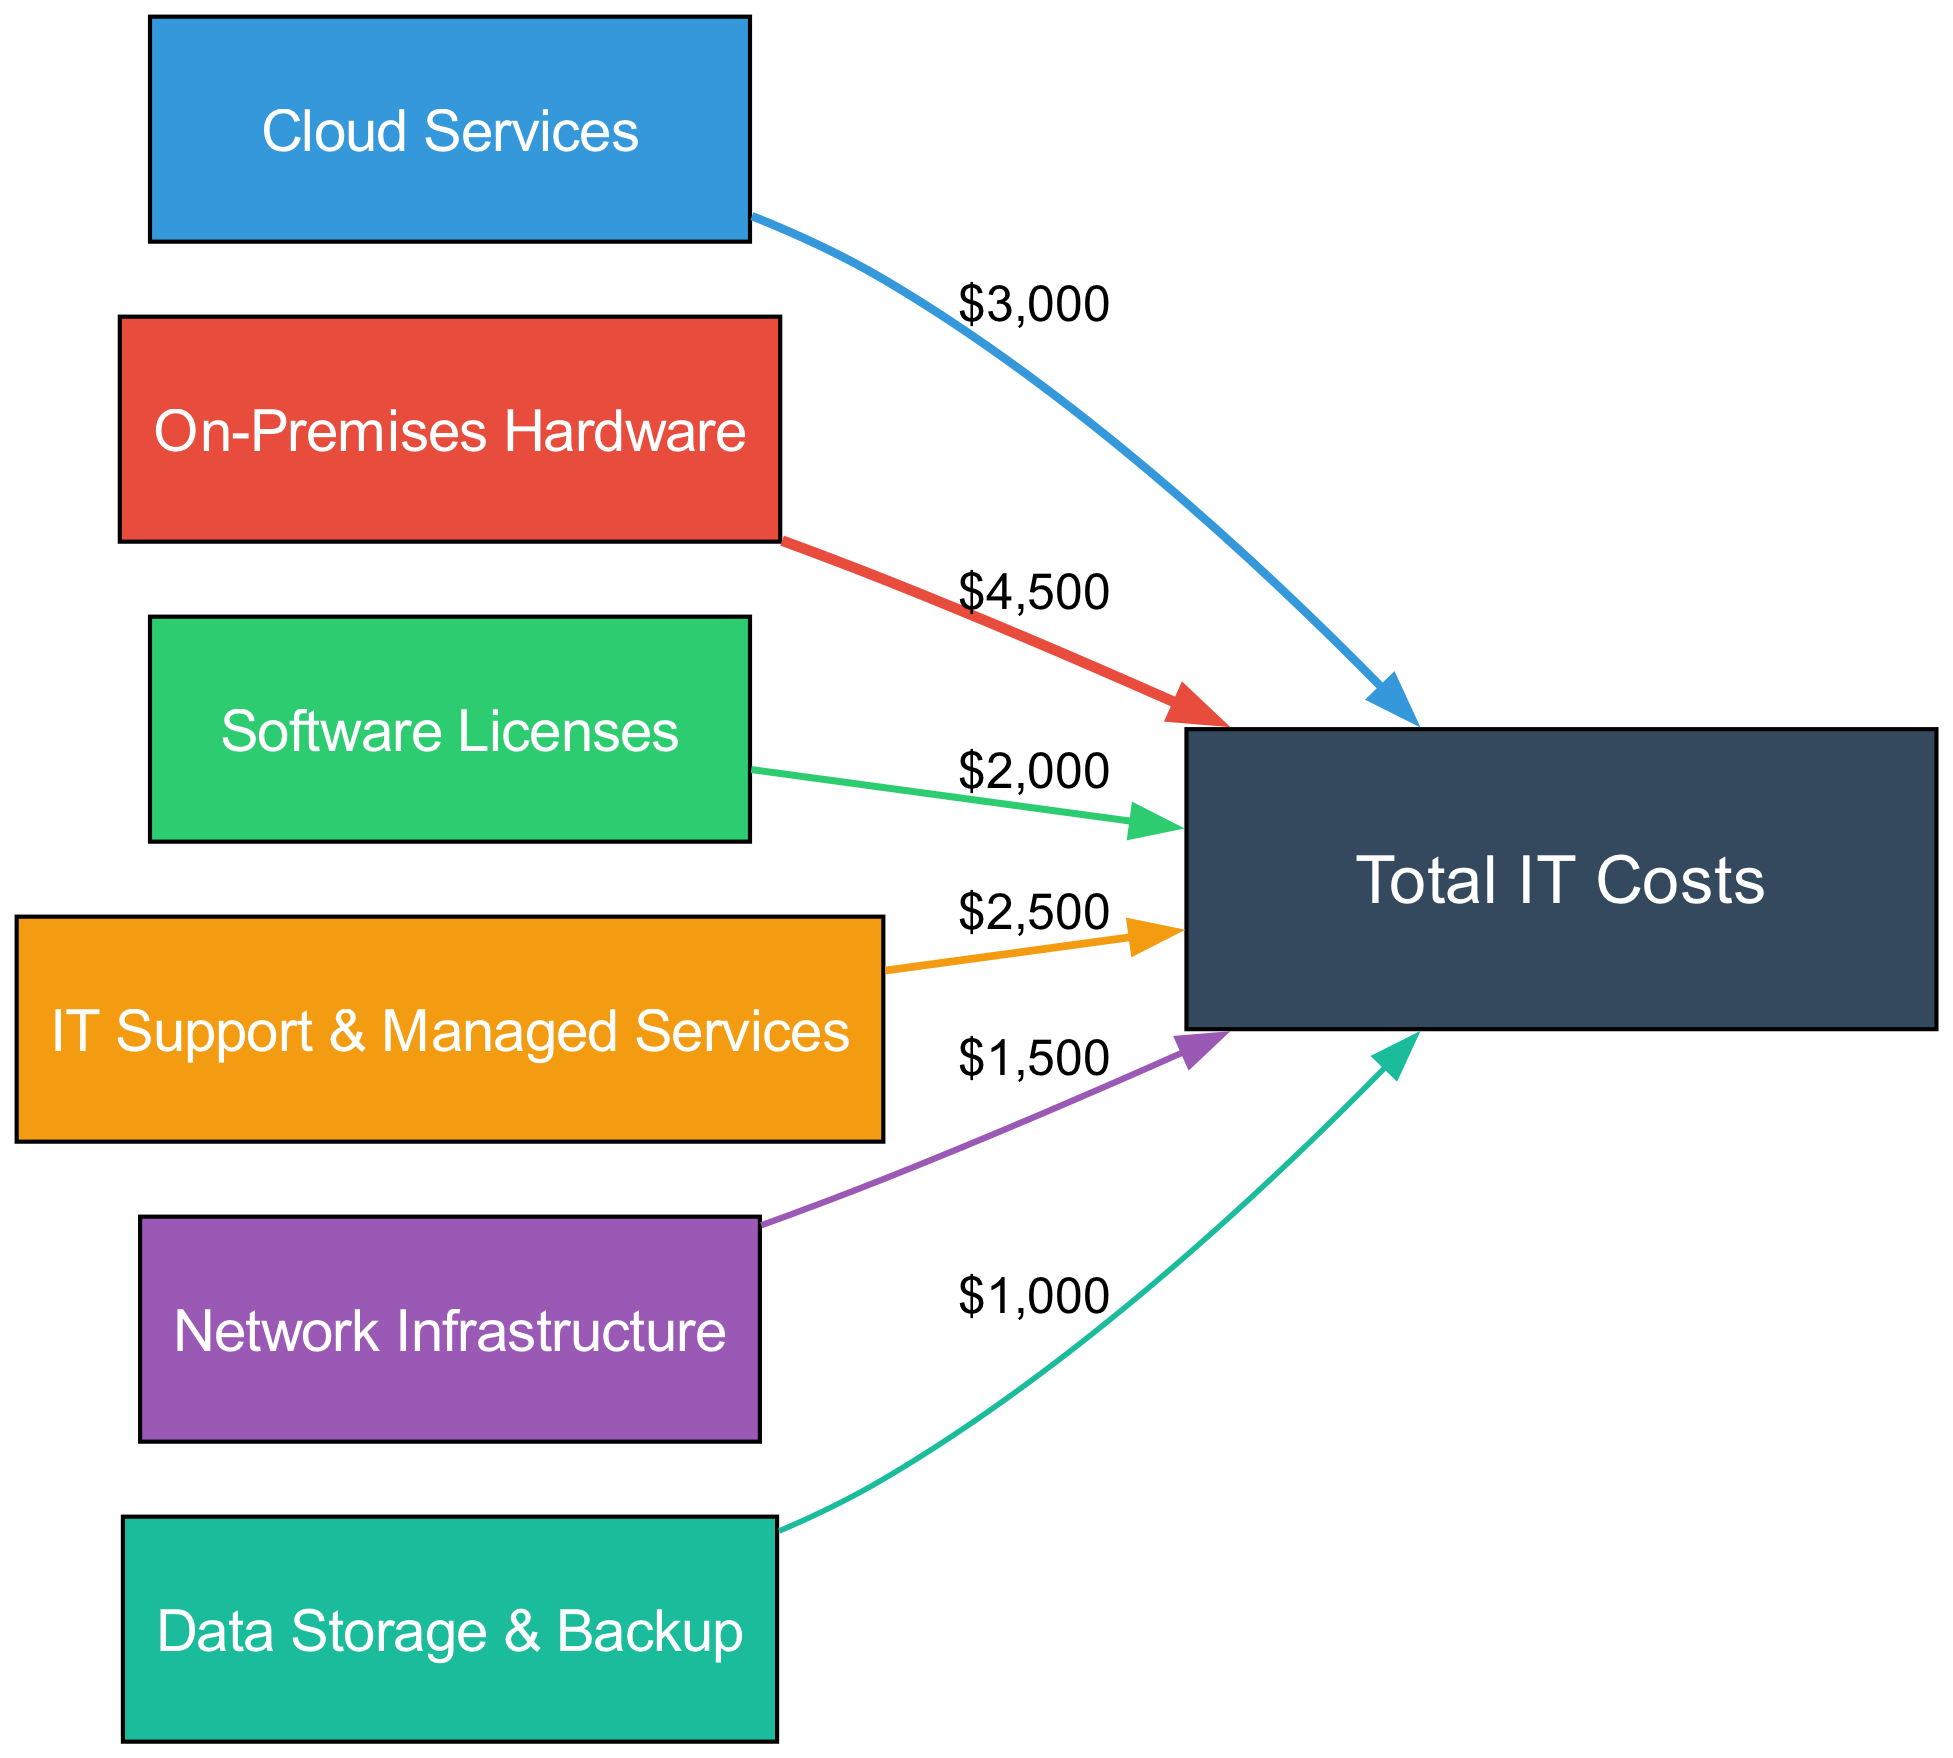What is the total monthly IT cost? The total monthly IT cost can be deduced from the sum of all the individual links (costs) leading to the node "Total IT Costs". By adding $3000 (Cloud Services) + $4500 (On-Premises Hardware) + $2000 (Software Licenses) + $2500 (IT Support & Managed Services) + $1500 (Network Infrastructure) + $1000 (Data Storage & Backup), we find the total is $15,500.
Answer: $15,500 Which component has the highest monthly expense? To determine the component with the highest monthly expense, we examine the individual values linked to each component: Cloud Services ($3000), On-Premises Hardware ($4500), Software Licenses ($2000), IT Support & Managed Services ($2500), Network Infrastructure ($1500), and Data Storage & Backup ($1000). The highest value is $4500 from On-Premises Hardware.
Answer: On-Premises Hardware How much do Cloud Services cost monthly? The Cloud Services node has a direct link to "Total IT Costs" with a specified expense of $3000. Therefore, we can directly state the cost.
Answer: $3000 What is the combined cost of IT Support and Software Licenses? The cost of IT Support & Managed Services is $2500 and Software Licenses is $2000. To find the combined cost, we add these two values together: $2500 + $2000 = $4500.
Answer: $4500 How many total links are there in the diagram? Each connection from the different components to "Total IT Costs" represents a link. Counting these, there are a total of six links: one for each component listed.
Answer: 6 What percentage of the total cost is contributed by Data Storage & Backup? To find the percentage contribution of Data Storage & Backup ($1000) to the total cost ($15,500), we use the formula: (cost of Data Storage & Backup / total cost) * 100. Thus, ($1000 / $15,500) * 100 gives approximately 6.45%.
Answer: 6.45% Which node has the least expense? By reviewing the expenses of each component linked to "Total IT Costs," we see Data Storage & Backup at $1000 is the least.
Answer: Data Storage & Backup What is the total combined cost of Cloud Services and Network Infrastructure? Cloud Services cost $3000 and Network Infrastructure costs $1500. Adding these together gives $3000 + $1500, which equals $4500.
Answer: $4500 